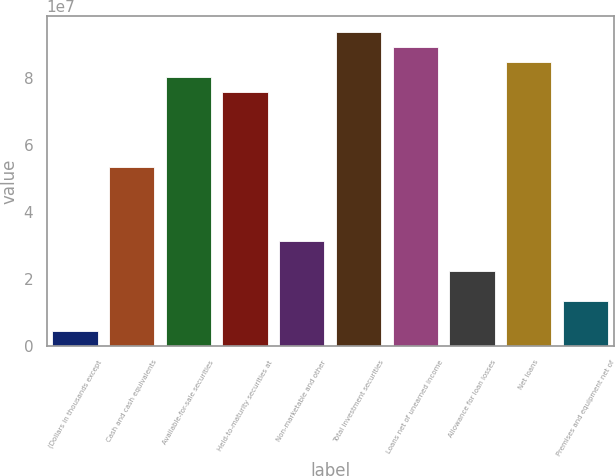Convert chart. <chart><loc_0><loc_0><loc_500><loc_500><bar_chart><fcel>(Dollars in thousands except<fcel>Cash and cash equivalents<fcel>Available-for-sale securities<fcel>Held-to-maturity securities at<fcel>Non-marketable and other<fcel>Total investment securities<fcel>Loans net of unearned income<fcel>Allowance for loan losses<fcel>Net loans<fcel>Premises and equipment net of<nl><fcel>4.46872e+06<fcel>5.3624e+07<fcel>8.0436e+07<fcel>7.59674e+07<fcel>3.12807e+07<fcel>9.3842e+07<fcel>8.93734e+07<fcel>2.23434e+07<fcel>8.49047e+07<fcel>1.3406e+07<nl></chart> 